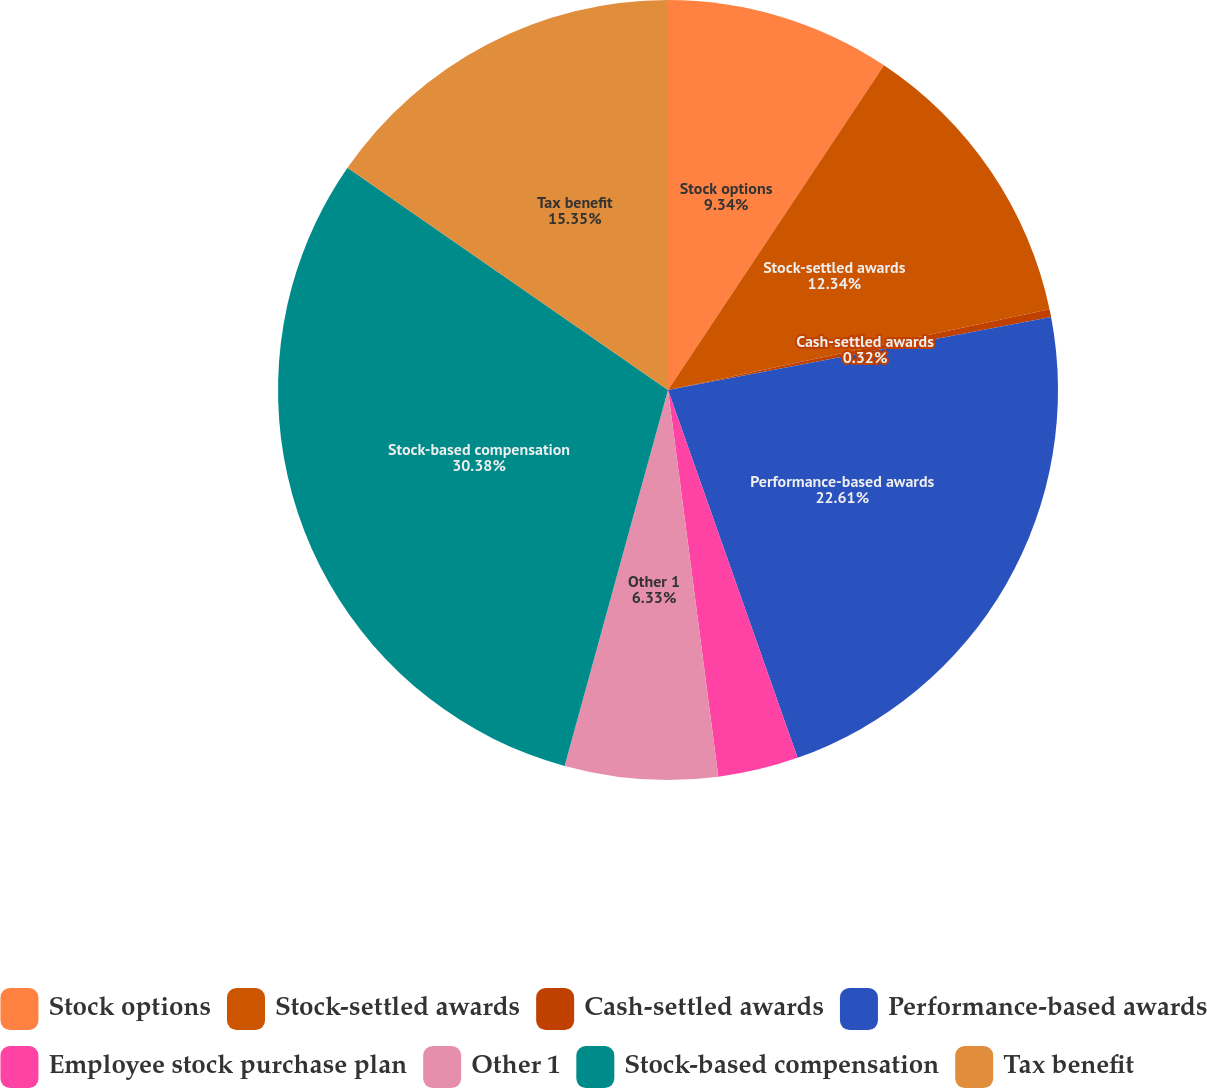Convert chart to OTSL. <chart><loc_0><loc_0><loc_500><loc_500><pie_chart><fcel>Stock options<fcel>Stock-settled awards<fcel>Cash-settled awards<fcel>Performance-based awards<fcel>Employee stock purchase plan<fcel>Other 1<fcel>Stock-based compensation<fcel>Tax benefit<nl><fcel>9.34%<fcel>12.34%<fcel>0.32%<fcel>22.61%<fcel>3.33%<fcel>6.33%<fcel>30.38%<fcel>15.35%<nl></chart> 